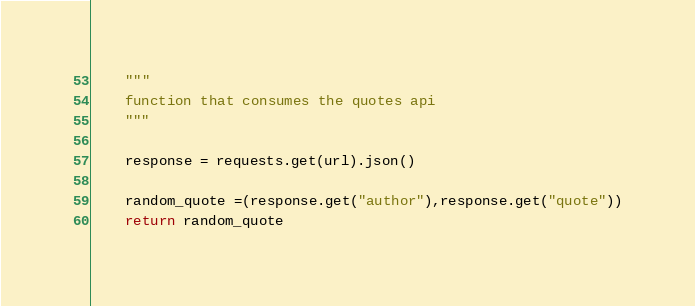<code> <loc_0><loc_0><loc_500><loc_500><_Python_>    """
    function that consumes the quotes api
    """

    response = requests.get(url).json()

    random_quote =(response.get("author"),response.get("quote"))
    return random_quote</code> 